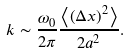Convert formula to latex. <formula><loc_0><loc_0><loc_500><loc_500>k \sim \frac { \omega _ { 0 } } { 2 \pi } \frac { \left \langle \left ( \Delta x \right ) ^ { 2 } \right \rangle } { 2 a ^ { 2 } } .</formula> 